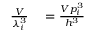Convert formula to latex. <formula><loc_0><loc_0><loc_500><loc_500>\begin{array} { r l } { \frac { V } { \lambda _ { i } ^ { 3 } } } & = \frac { V p _ { i } ^ { 3 } } { h ^ { 3 } } } \end{array}</formula> 